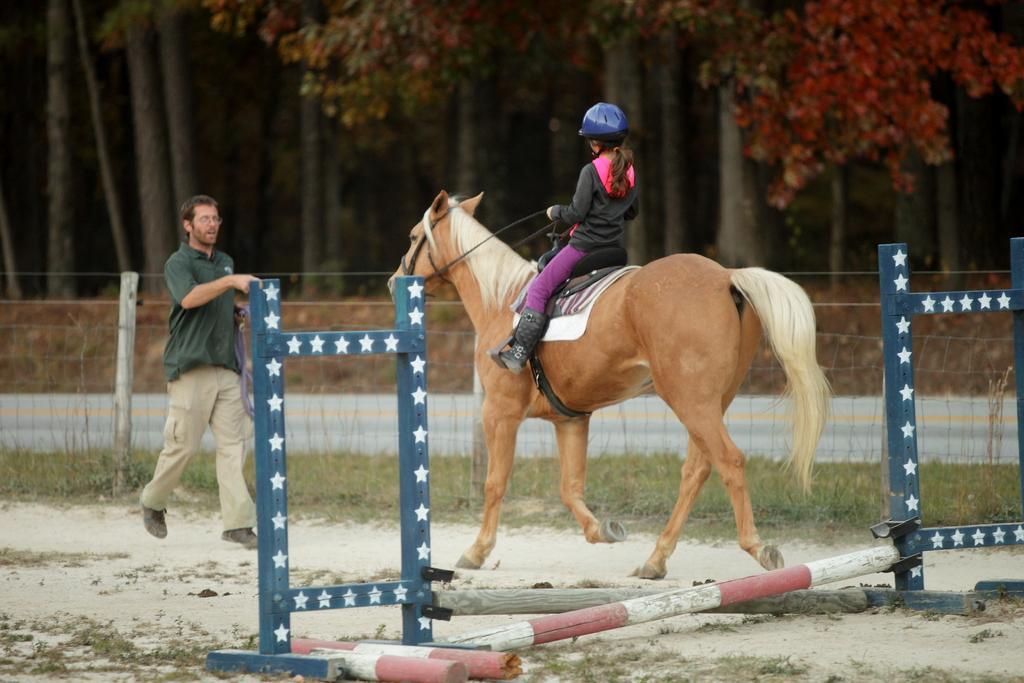How would you summarize this image in a sentence or two? In this image, we can see a girl is riding a horse on the ground and wearing a helmet. Here a person is walking and wearing glasses. He is holding some objects and talking. Here we can see few poles, grass, fencing, rods. Background there are so many trees and road. 